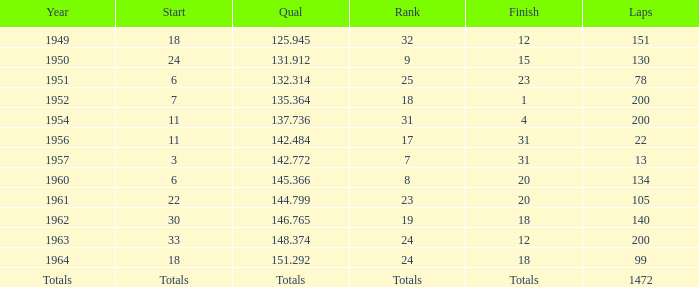Name the rank with finish of 12 and year of 1963 24.0. 